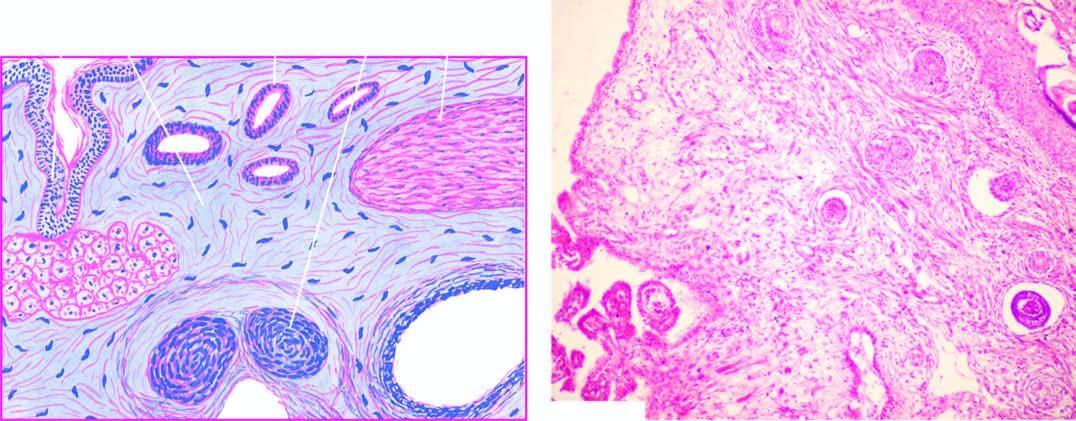what shows a variety of incompletely differentiated tissue elements?
Answer the question using a single word or phrase. Microscopy 